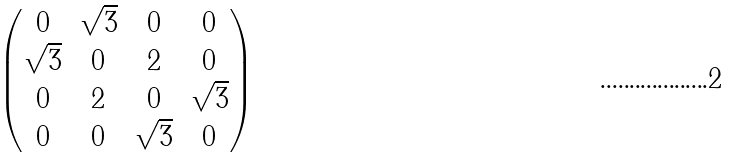Convert formula to latex. <formula><loc_0><loc_0><loc_500><loc_500>\begin{pmatrix} 0 & \sqrt { 3 } & 0 & 0 \\ \sqrt { 3 } & 0 & 2 & 0 \\ 0 & 2 & 0 & \sqrt { 3 } \\ 0 & 0 & \sqrt { 3 } & 0 \end{pmatrix}</formula> 